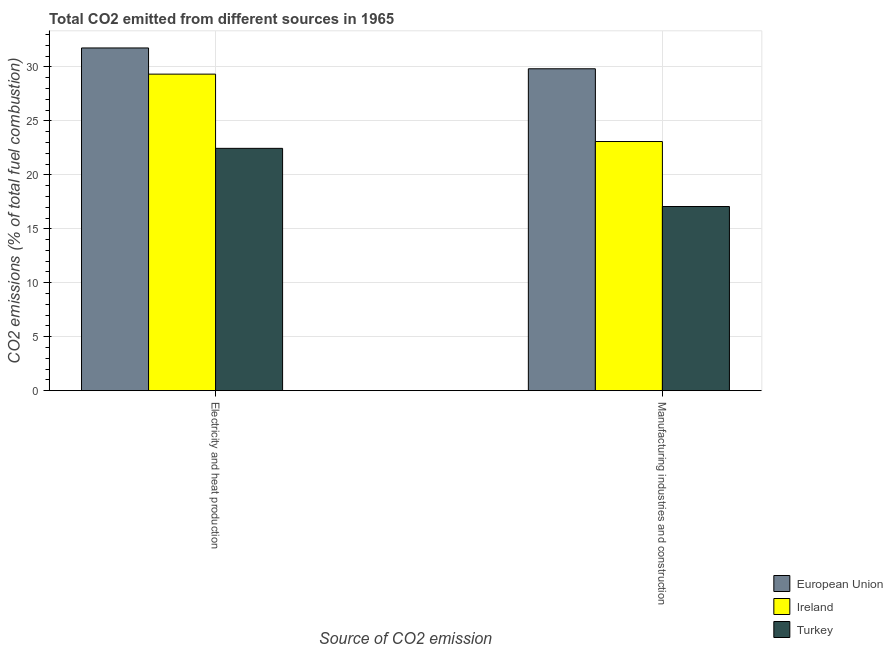Are the number of bars per tick equal to the number of legend labels?
Keep it short and to the point. Yes. How many bars are there on the 2nd tick from the left?
Make the answer very short. 3. How many bars are there on the 1st tick from the right?
Provide a succinct answer. 3. What is the label of the 2nd group of bars from the left?
Provide a succinct answer. Manufacturing industries and construction. What is the co2 emissions due to manufacturing industries in Turkey?
Offer a very short reply. 17.07. Across all countries, what is the maximum co2 emissions due to manufacturing industries?
Offer a terse response. 29.83. Across all countries, what is the minimum co2 emissions due to electricity and heat production?
Give a very brief answer. 22.46. In which country was the co2 emissions due to manufacturing industries minimum?
Offer a terse response. Turkey. What is the total co2 emissions due to electricity and heat production in the graph?
Keep it short and to the point. 83.55. What is the difference between the co2 emissions due to electricity and heat production in Ireland and that in European Union?
Offer a terse response. -2.43. What is the difference between the co2 emissions due to electricity and heat production in European Union and the co2 emissions due to manufacturing industries in Turkey?
Ensure brevity in your answer.  14.69. What is the average co2 emissions due to manufacturing industries per country?
Your response must be concise. 23.33. What is the difference between the co2 emissions due to manufacturing industries and co2 emissions due to electricity and heat production in European Union?
Ensure brevity in your answer.  -1.93. In how many countries, is the co2 emissions due to electricity and heat production greater than 6 %?
Offer a very short reply. 3. What is the ratio of the co2 emissions due to electricity and heat production in Ireland to that in Turkey?
Your answer should be very brief. 1.31. Is the co2 emissions due to manufacturing industries in European Union less than that in Turkey?
Keep it short and to the point. No. What does the 2nd bar from the left in Manufacturing industries and construction represents?
Keep it short and to the point. Ireland. What does the 1st bar from the right in Manufacturing industries and construction represents?
Provide a succinct answer. Turkey. How many bars are there?
Offer a very short reply. 6. Are all the bars in the graph horizontal?
Ensure brevity in your answer.  No. How many countries are there in the graph?
Make the answer very short. 3. What is the difference between two consecutive major ticks on the Y-axis?
Your answer should be compact. 5. Does the graph contain any zero values?
Offer a very short reply. No. Does the graph contain grids?
Your response must be concise. Yes. How many legend labels are there?
Your answer should be very brief. 3. How are the legend labels stacked?
Give a very brief answer. Vertical. What is the title of the graph?
Your response must be concise. Total CO2 emitted from different sources in 1965. Does "Pacific island small states" appear as one of the legend labels in the graph?
Offer a terse response. No. What is the label or title of the X-axis?
Keep it short and to the point. Source of CO2 emission. What is the label or title of the Y-axis?
Offer a very short reply. CO2 emissions (% of total fuel combustion). What is the CO2 emissions (% of total fuel combustion) in European Union in Electricity and heat production?
Keep it short and to the point. 31.76. What is the CO2 emissions (% of total fuel combustion) in Ireland in Electricity and heat production?
Your answer should be very brief. 29.33. What is the CO2 emissions (% of total fuel combustion) in Turkey in Electricity and heat production?
Provide a succinct answer. 22.46. What is the CO2 emissions (% of total fuel combustion) of European Union in Manufacturing industries and construction?
Make the answer very short. 29.83. What is the CO2 emissions (% of total fuel combustion) in Ireland in Manufacturing industries and construction?
Provide a short and direct response. 23.09. What is the CO2 emissions (% of total fuel combustion) in Turkey in Manufacturing industries and construction?
Give a very brief answer. 17.07. Across all Source of CO2 emission, what is the maximum CO2 emissions (% of total fuel combustion) in European Union?
Offer a terse response. 31.76. Across all Source of CO2 emission, what is the maximum CO2 emissions (% of total fuel combustion) in Ireland?
Provide a short and direct response. 29.33. Across all Source of CO2 emission, what is the maximum CO2 emissions (% of total fuel combustion) of Turkey?
Provide a short and direct response. 22.46. Across all Source of CO2 emission, what is the minimum CO2 emissions (% of total fuel combustion) in European Union?
Make the answer very short. 29.83. Across all Source of CO2 emission, what is the minimum CO2 emissions (% of total fuel combustion) of Ireland?
Offer a terse response. 23.09. Across all Source of CO2 emission, what is the minimum CO2 emissions (% of total fuel combustion) of Turkey?
Provide a succinct answer. 17.07. What is the total CO2 emissions (% of total fuel combustion) in European Union in the graph?
Your response must be concise. 61.59. What is the total CO2 emissions (% of total fuel combustion) of Ireland in the graph?
Ensure brevity in your answer.  52.42. What is the total CO2 emissions (% of total fuel combustion) of Turkey in the graph?
Keep it short and to the point. 39.52. What is the difference between the CO2 emissions (% of total fuel combustion) in European Union in Electricity and heat production and that in Manufacturing industries and construction?
Make the answer very short. 1.93. What is the difference between the CO2 emissions (% of total fuel combustion) in Ireland in Electricity and heat production and that in Manufacturing industries and construction?
Offer a terse response. 6.25. What is the difference between the CO2 emissions (% of total fuel combustion) in Turkey in Electricity and heat production and that in Manufacturing industries and construction?
Provide a succinct answer. 5.39. What is the difference between the CO2 emissions (% of total fuel combustion) of European Union in Electricity and heat production and the CO2 emissions (% of total fuel combustion) of Ireland in Manufacturing industries and construction?
Provide a succinct answer. 8.67. What is the difference between the CO2 emissions (% of total fuel combustion) in European Union in Electricity and heat production and the CO2 emissions (% of total fuel combustion) in Turkey in Manufacturing industries and construction?
Provide a succinct answer. 14.69. What is the difference between the CO2 emissions (% of total fuel combustion) in Ireland in Electricity and heat production and the CO2 emissions (% of total fuel combustion) in Turkey in Manufacturing industries and construction?
Your answer should be very brief. 12.27. What is the average CO2 emissions (% of total fuel combustion) in European Union per Source of CO2 emission?
Provide a succinct answer. 30.8. What is the average CO2 emissions (% of total fuel combustion) of Ireland per Source of CO2 emission?
Your response must be concise. 26.21. What is the average CO2 emissions (% of total fuel combustion) in Turkey per Source of CO2 emission?
Ensure brevity in your answer.  19.76. What is the difference between the CO2 emissions (% of total fuel combustion) of European Union and CO2 emissions (% of total fuel combustion) of Ireland in Electricity and heat production?
Provide a short and direct response. 2.43. What is the difference between the CO2 emissions (% of total fuel combustion) of European Union and CO2 emissions (% of total fuel combustion) of Turkey in Electricity and heat production?
Provide a succinct answer. 9.3. What is the difference between the CO2 emissions (% of total fuel combustion) of Ireland and CO2 emissions (% of total fuel combustion) of Turkey in Electricity and heat production?
Ensure brevity in your answer.  6.88. What is the difference between the CO2 emissions (% of total fuel combustion) in European Union and CO2 emissions (% of total fuel combustion) in Ireland in Manufacturing industries and construction?
Provide a short and direct response. 6.74. What is the difference between the CO2 emissions (% of total fuel combustion) in European Union and CO2 emissions (% of total fuel combustion) in Turkey in Manufacturing industries and construction?
Keep it short and to the point. 12.76. What is the difference between the CO2 emissions (% of total fuel combustion) of Ireland and CO2 emissions (% of total fuel combustion) of Turkey in Manufacturing industries and construction?
Offer a very short reply. 6.02. What is the ratio of the CO2 emissions (% of total fuel combustion) in European Union in Electricity and heat production to that in Manufacturing industries and construction?
Provide a short and direct response. 1.06. What is the ratio of the CO2 emissions (% of total fuel combustion) of Ireland in Electricity and heat production to that in Manufacturing industries and construction?
Provide a short and direct response. 1.27. What is the ratio of the CO2 emissions (% of total fuel combustion) in Turkey in Electricity and heat production to that in Manufacturing industries and construction?
Your answer should be compact. 1.32. What is the difference between the highest and the second highest CO2 emissions (% of total fuel combustion) in European Union?
Your answer should be compact. 1.93. What is the difference between the highest and the second highest CO2 emissions (% of total fuel combustion) of Ireland?
Offer a very short reply. 6.25. What is the difference between the highest and the second highest CO2 emissions (% of total fuel combustion) of Turkey?
Your response must be concise. 5.39. What is the difference between the highest and the lowest CO2 emissions (% of total fuel combustion) in European Union?
Offer a terse response. 1.93. What is the difference between the highest and the lowest CO2 emissions (% of total fuel combustion) in Ireland?
Provide a short and direct response. 6.25. What is the difference between the highest and the lowest CO2 emissions (% of total fuel combustion) in Turkey?
Your answer should be compact. 5.39. 